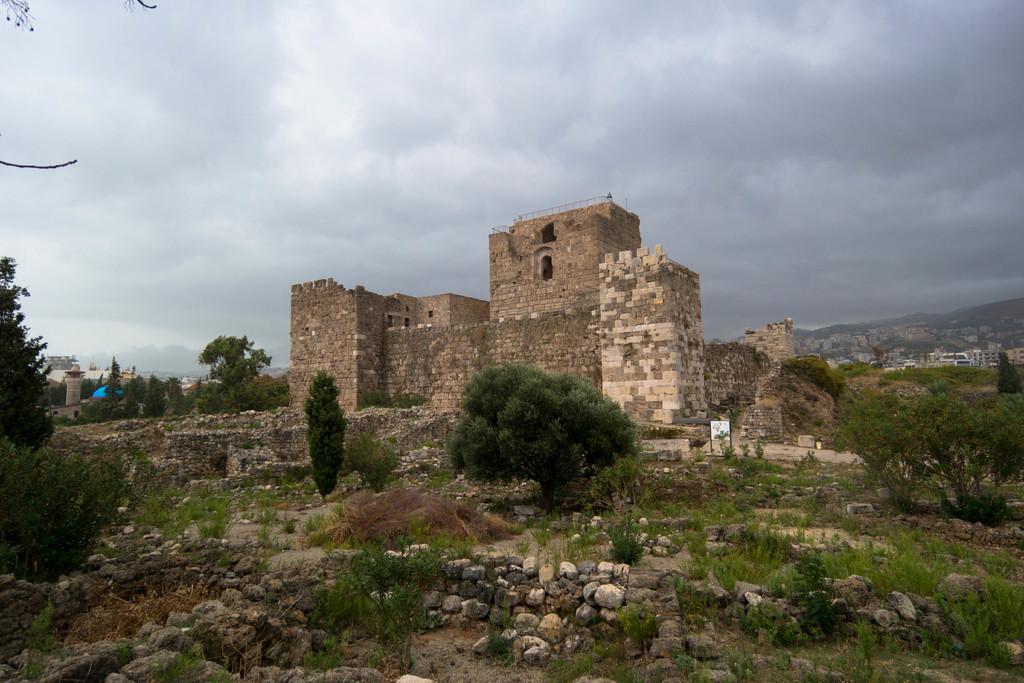In one or two sentences, can you explain what this image depicts? In this image we can see a building, in front of the building there are trees, grass and stones and in the background there are few buildings and sky with clouds. 